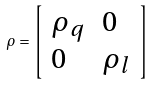Convert formula to latex. <formula><loc_0><loc_0><loc_500><loc_500>\rho = \left [ \begin{array} { l l } \rho _ { q } & 0 \\ 0 & \rho _ { l } \end{array} \right ]</formula> 